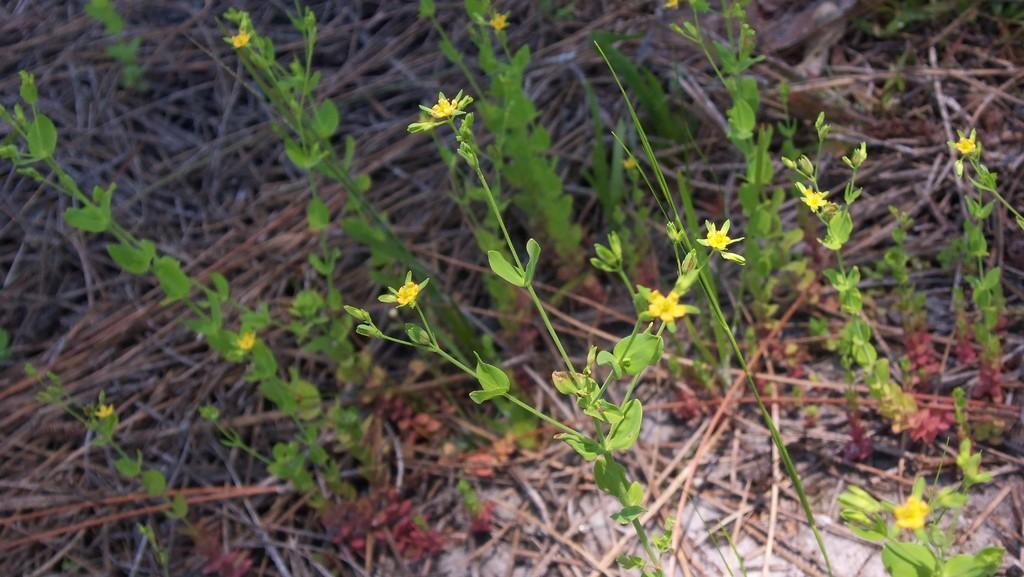What type of plants can be seen in the image? There are flower plants in the image. What color are the flowers on the plants? The flowers are yellow in color. Can you describe the background of the image? The background of the image is blurred. What type of cabbage is growing in the image? There is no cabbage present in the image; it features flower plants with yellow flowers. How many stems can be seen on the cabbage in the image? There is no cabbage in the image, so it is not possible to determine the number of stems. 